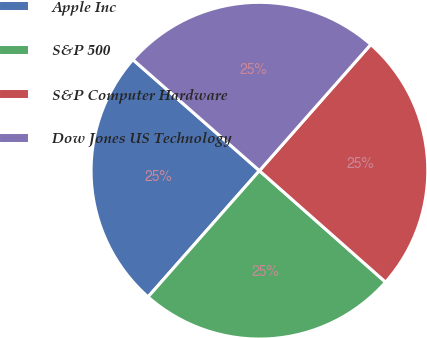<chart> <loc_0><loc_0><loc_500><loc_500><pie_chart><fcel>Apple Inc<fcel>S&P 500<fcel>S&P Computer Hardware<fcel>Dow Jones US Technology<nl><fcel>24.96%<fcel>24.99%<fcel>25.01%<fcel>25.04%<nl></chart> 